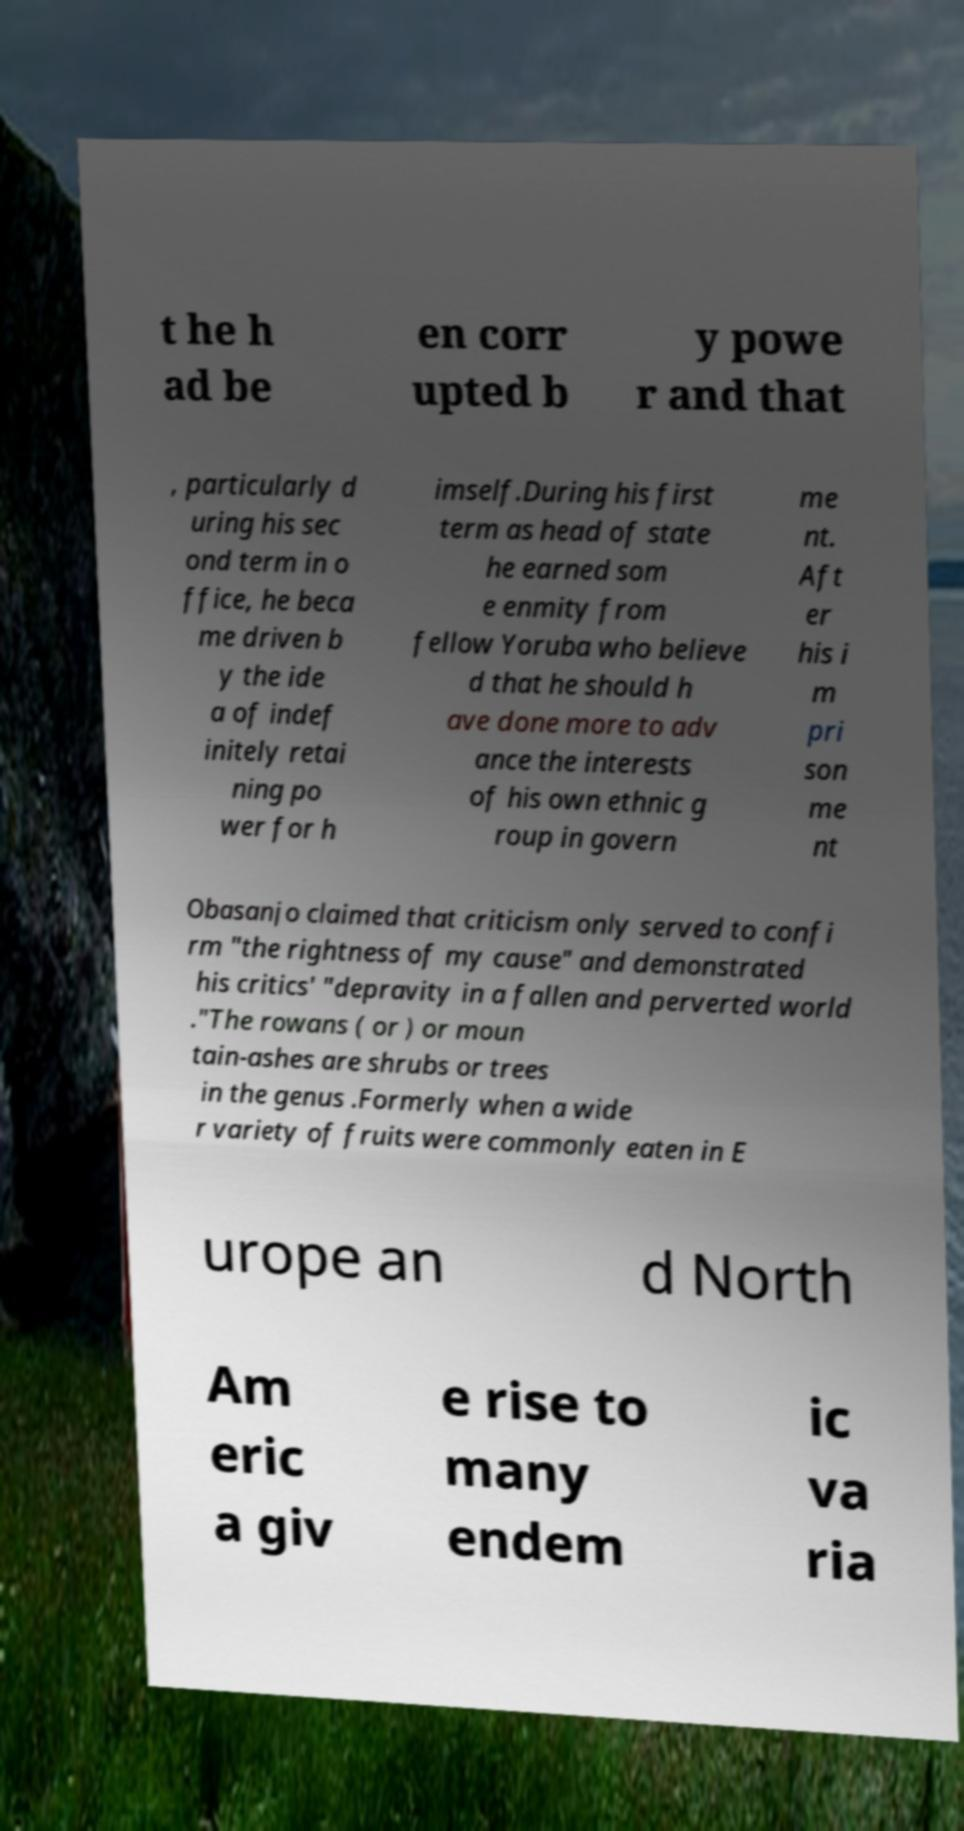I need the written content from this picture converted into text. Can you do that? t he h ad be en corr upted b y powe r and that , particularly d uring his sec ond term in o ffice, he beca me driven b y the ide a of indef initely retai ning po wer for h imself.During his first term as head of state he earned som e enmity from fellow Yoruba who believe d that he should h ave done more to adv ance the interests of his own ethnic g roup in govern me nt. Aft er his i m pri son me nt Obasanjo claimed that criticism only served to confi rm "the rightness of my cause" and demonstrated his critics' "depravity in a fallen and perverted world ."The rowans ( or ) or moun tain-ashes are shrubs or trees in the genus .Formerly when a wide r variety of fruits were commonly eaten in E urope an d North Am eric a giv e rise to many endem ic va ria 